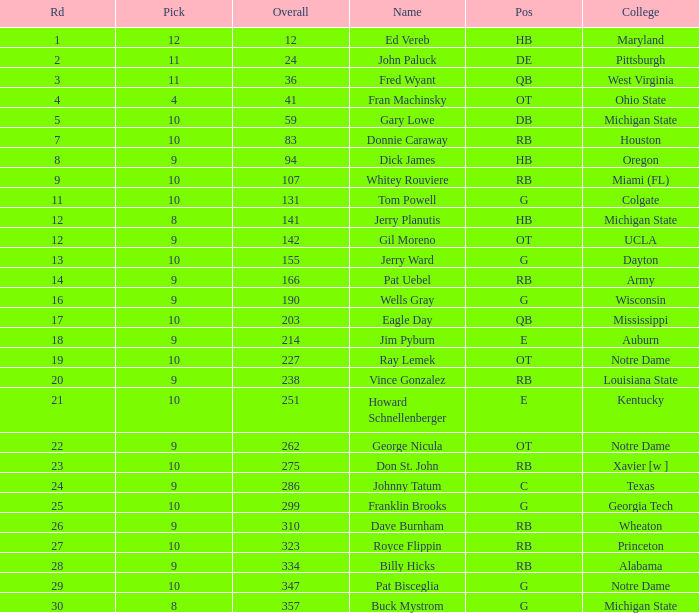What is the sum of rounds that has a pick of 9 and is named jim pyburn? 18.0. 